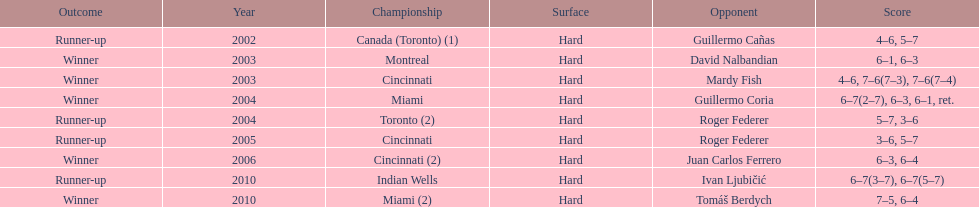In miami, how many instances of the championship have occurred? 2. 